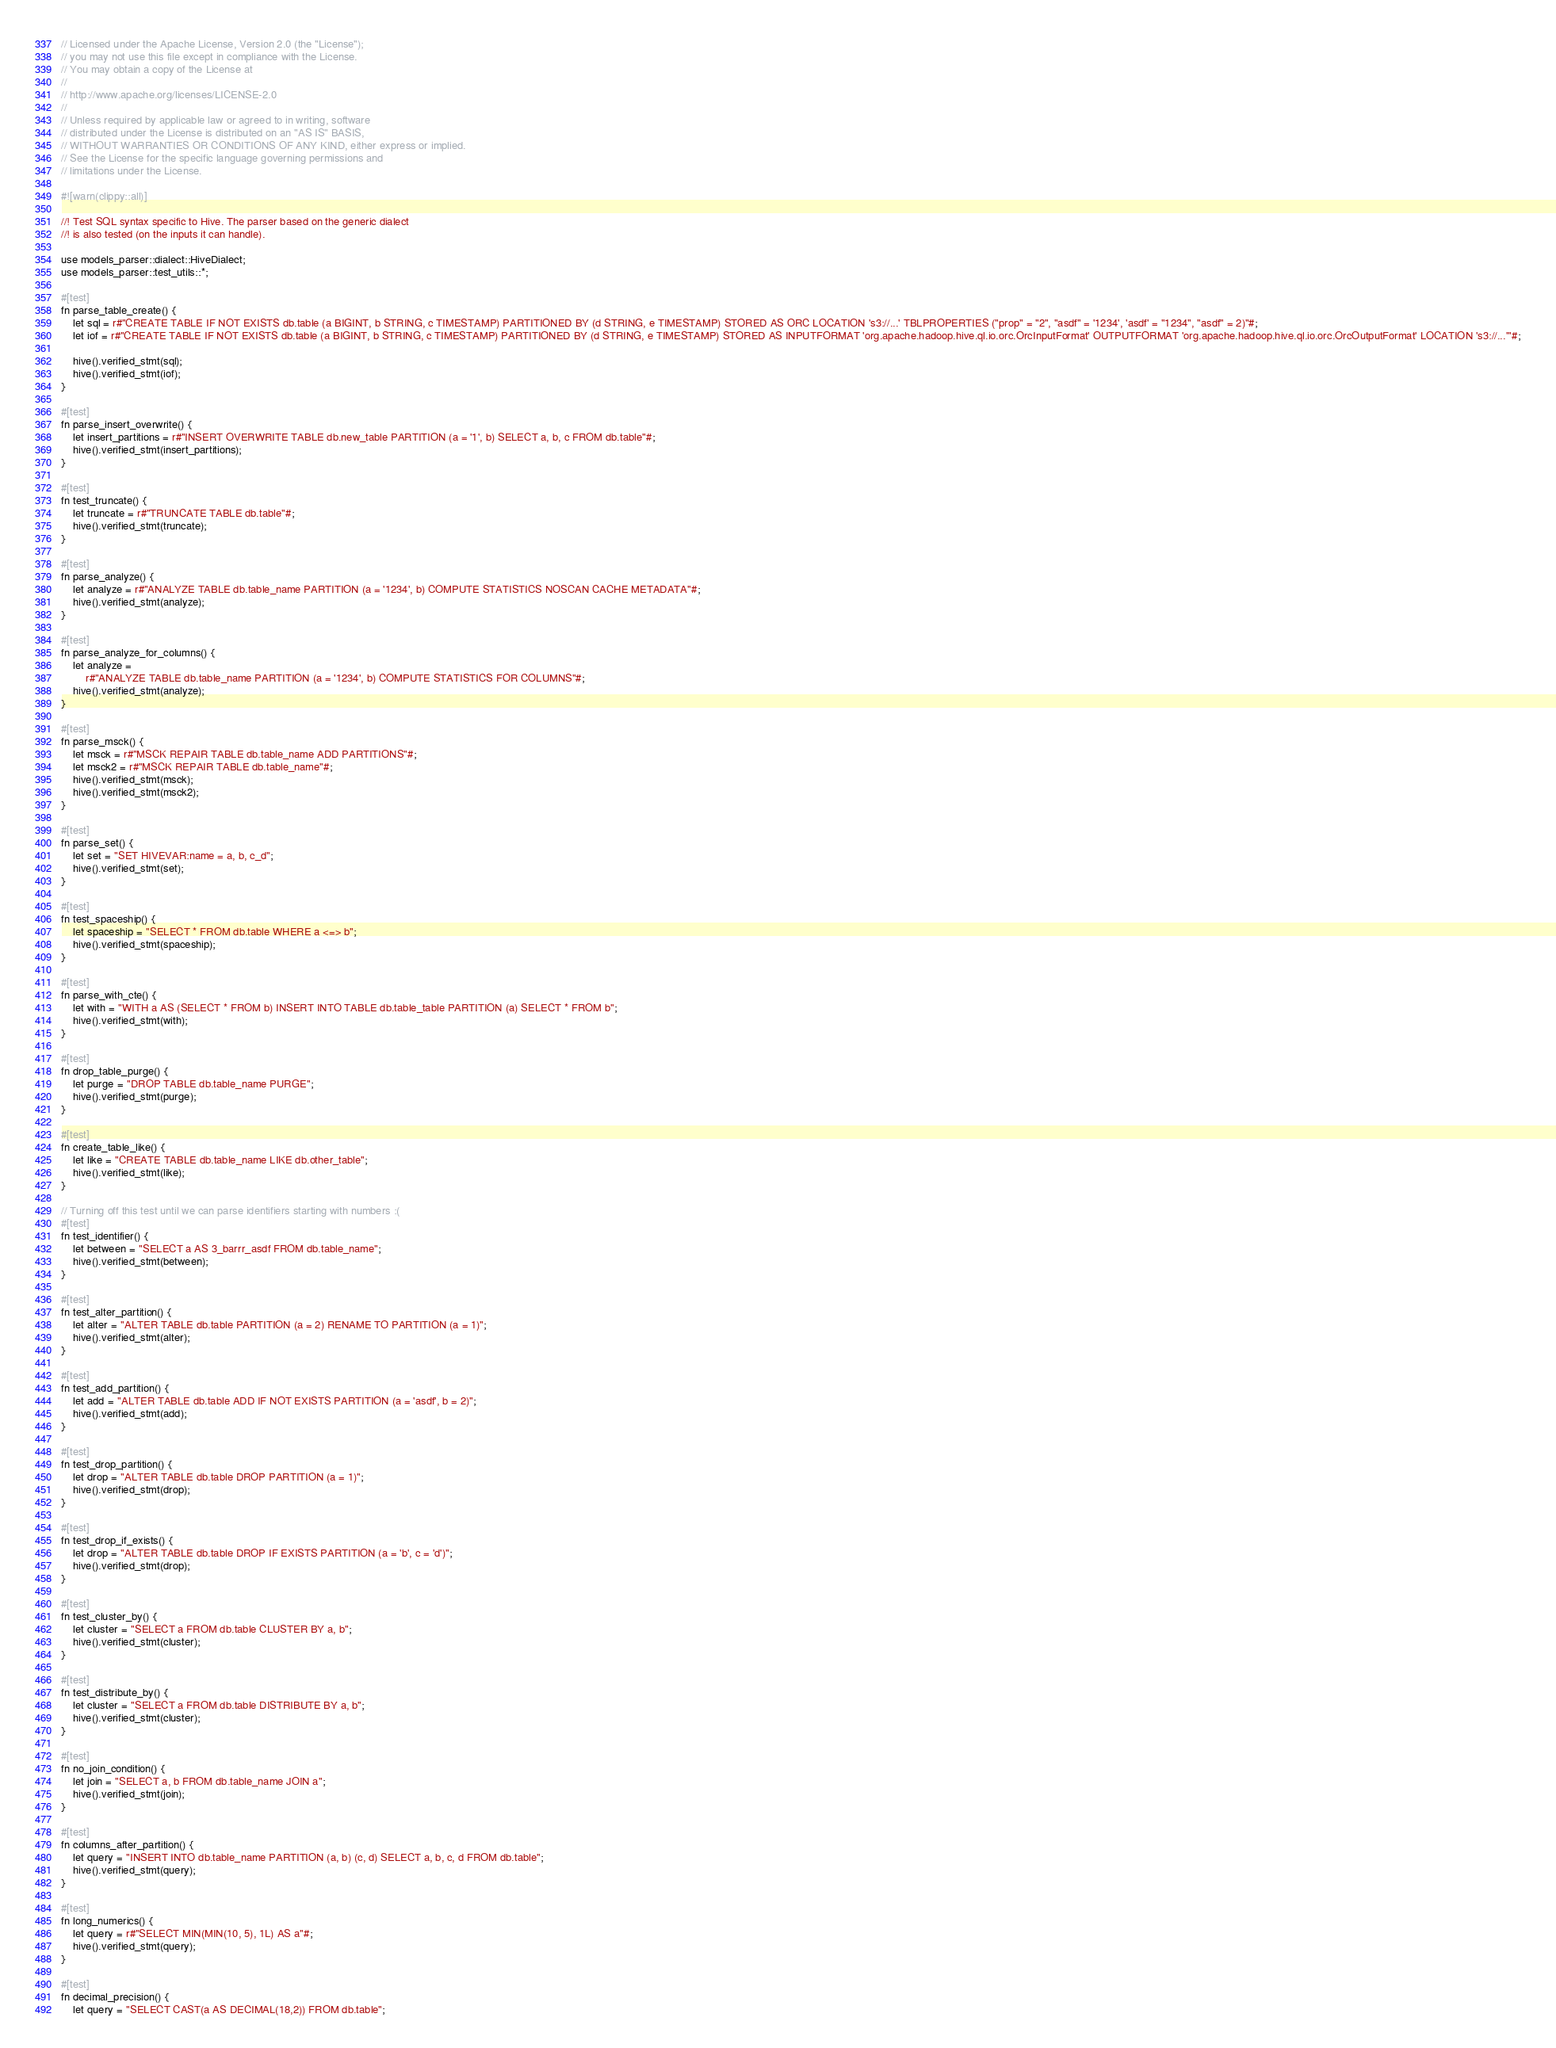<code> <loc_0><loc_0><loc_500><loc_500><_Rust_>// Licensed under the Apache License, Version 2.0 (the "License");
// you may not use this file except in compliance with the License.
// You may obtain a copy of the License at
//
// http://www.apache.org/licenses/LICENSE-2.0
//
// Unless required by applicable law or agreed to in writing, software
// distributed under the License is distributed on an "AS IS" BASIS,
// WITHOUT WARRANTIES OR CONDITIONS OF ANY KIND, either express or implied.
// See the License for the specific language governing permissions and
// limitations under the License.

#![warn(clippy::all)]

//! Test SQL syntax specific to Hive. The parser based on the generic dialect
//! is also tested (on the inputs it can handle).

use models_parser::dialect::HiveDialect;
use models_parser::test_utils::*;

#[test]
fn parse_table_create() {
    let sql = r#"CREATE TABLE IF NOT EXISTS db.table (a BIGINT, b STRING, c TIMESTAMP) PARTITIONED BY (d STRING, e TIMESTAMP) STORED AS ORC LOCATION 's3://...' TBLPROPERTIES ("prop" = "2", "asdf" = '1234', 'asdf' = "1234", "asdf" = 2)"#;
    let iof = r#"CREATE TABLE IF NOT EXISTS db.table (a BIGINT, b STRING, c TIMESTAMP) PARTITIONED BY (d STRING, e TIMESTAMP) STORED AS INPUTFORMAT 'org.apache.hadoop.hive.ql.io.orc.OrcInputFormat' OUTPUTFORMAT 'org.apache.hadoop.hive.ql.io.orc.OrcOutputFormat' LOCATION 's3://...'"#;

    hive().verified_stmt(sql);
    hive().verified_stmt(iof);
}

#[test]
fn parse_insert_overwrite() {
    let insert_partitions = r#"INSERT OVERWRITE TABLE db.new_table PARTITION (a = '1', b) SELECT a, b, c FROM db.table"#;
    hive().verified_stmt(insert_partitions);
}

#[test]
fn test_truncate() {
    let truncate = r#"TRUNCATE TABLE db.table"#;
    hive().verified_stmt(truncate);
}

#[test]
fn parse_analyze() {
    let analyze = r#"ANALYZE TABLE db.table_name PARTITION (a = '1234', b) COMPUTE STATISTICS NOSCAN CACHE METADATA"#;
    hive().verified_stmt(analyze);
}

#[test]
fn parse_analyze_for_columns() {
    let analyze =
        r#"ANALYZE TABLE db.table_name PARTITION (a = '1234', b) COMPUTE STATISTICS FOR COLUMNS"#;
    hive().verified_stmt(analyze);
}

#[test]
fn parse_msck() {
    let msck = r#"MSCK REPAIR TABLE db.table_name ADD PARTITIONS"#;
    let msck2 = r#"MSCK REPAIR TABLE db.table_name"#;
    hive().verified_stmt(msck);
    hive().verified_stmt(msck2);
}

#[test]
fn parse_set() {
    let set = "SET HIVEVAR:name = a, b, c_d";
    hive().verified_stmt(set);
}

#[test]
fn test_spaceship() {
    let spaceship = "SELECT * FROM db.table WHERE a <=> b";
    hive().verified_stmt(spaceship);
}

#[test]
fn parse_with_cte() {
    let with = "WITH a AS (SELECT * FROM b) INSERT INTO TABLE db.table_table PARTITION (a) SELECT * FROM b";
    hive().verified_stmt(with);
}

#[test]
fn drop_table_purge() {
    let purge = "DROP TABLE db.table_name PURGE";
    hive().verified_stmt(purge);
}

#[test]
fn create_table_like() {
    let like = "CREATE TABLE db.table_name LIKE db.other_table";
    hive().verified_stmt(like);
}

// Turning off this test until we can parse identifiers starting with numbers :(
#[test]
fn test_identifier() {
    let between = "SELECT a AS 3_barrr_asdf FROM db.table_name";
    hive().verified_stmt(between);
}

#[test]
fn test_alter_partition() {
    let alter = "ALTER TABLE db.table PARTITION (a = 2) RENAME TO PARTITION (a = 1)";
    hive().verified_stmt(alter);
}

#[test]
fn test_add_partition() {
    let add = "ALTER TABLE db.table ADD IF NOT EXISTS PARTITION (a = 'asdf', b = 2)";
    hive().verified_stmt(add);
}

#[test]
fn test_drop_partition() {
    let drop = "ALTER TABLE db.table DROP PARTITION (a = 1)";
    hive().verified_stmt(drop);
}

#[test]
fn test_drop_if_exists() {
    let drop = "ALTER TABLE db.table DROP IF EXISTS PARTITION (a = 'b', c = 'd')";
    hive().verified_stmt(drop);
}

#[test]
fn test_cluster_by() {
    let cluster = "SELECT a FROM db.table CLUSTER BY a, b";
    hive().verified_stmt(cluster);
}

#[test]
fn test_distribute_by() {
    let cluster = "SELECT a FROM db.table DISTRIBUTE BY a, b";
    hive().verified_stmt(cluster);
}

#[test]
fn no_join_condition() {
    let join = "SELECT a, b FROM db.table_name JOIN a";
    hive().verified_stmt(join);
}

#[test]
fn columns_after_partition() {
    let query = "INSERT INTO db.table_name PARTITION (a, b) (c, d) SELECT a, b, c, d FROM db.table";
    hive().verified_stmt(query);
}

#[test]
fn long_numerics() {
    let query = r#"SELECT MIN(MIN(10, 5), 1L) AS a"#;
    hive().verified_stmt(query);
}

#[test]
fn decimal_precision() {
    let query = "SELECT CAST(a AS DECIMAL(18,2)) FROM db.table";</code> 